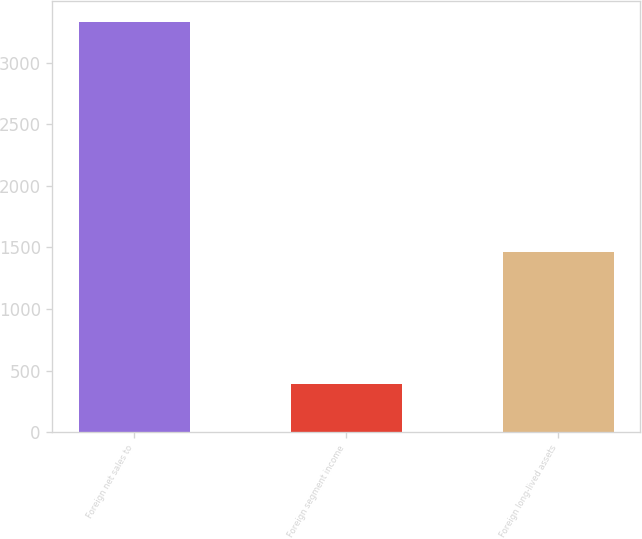<chart> <loc_0><loc_0><loc_500><loc_500><bar_chart><fcel>Foreign net sales to<fcel>Foreign segment income<fcel>Foreign long-lived assets<nl><fcel>3332.4<fcel>392.3<fcel>1466.4<nl></chart> 